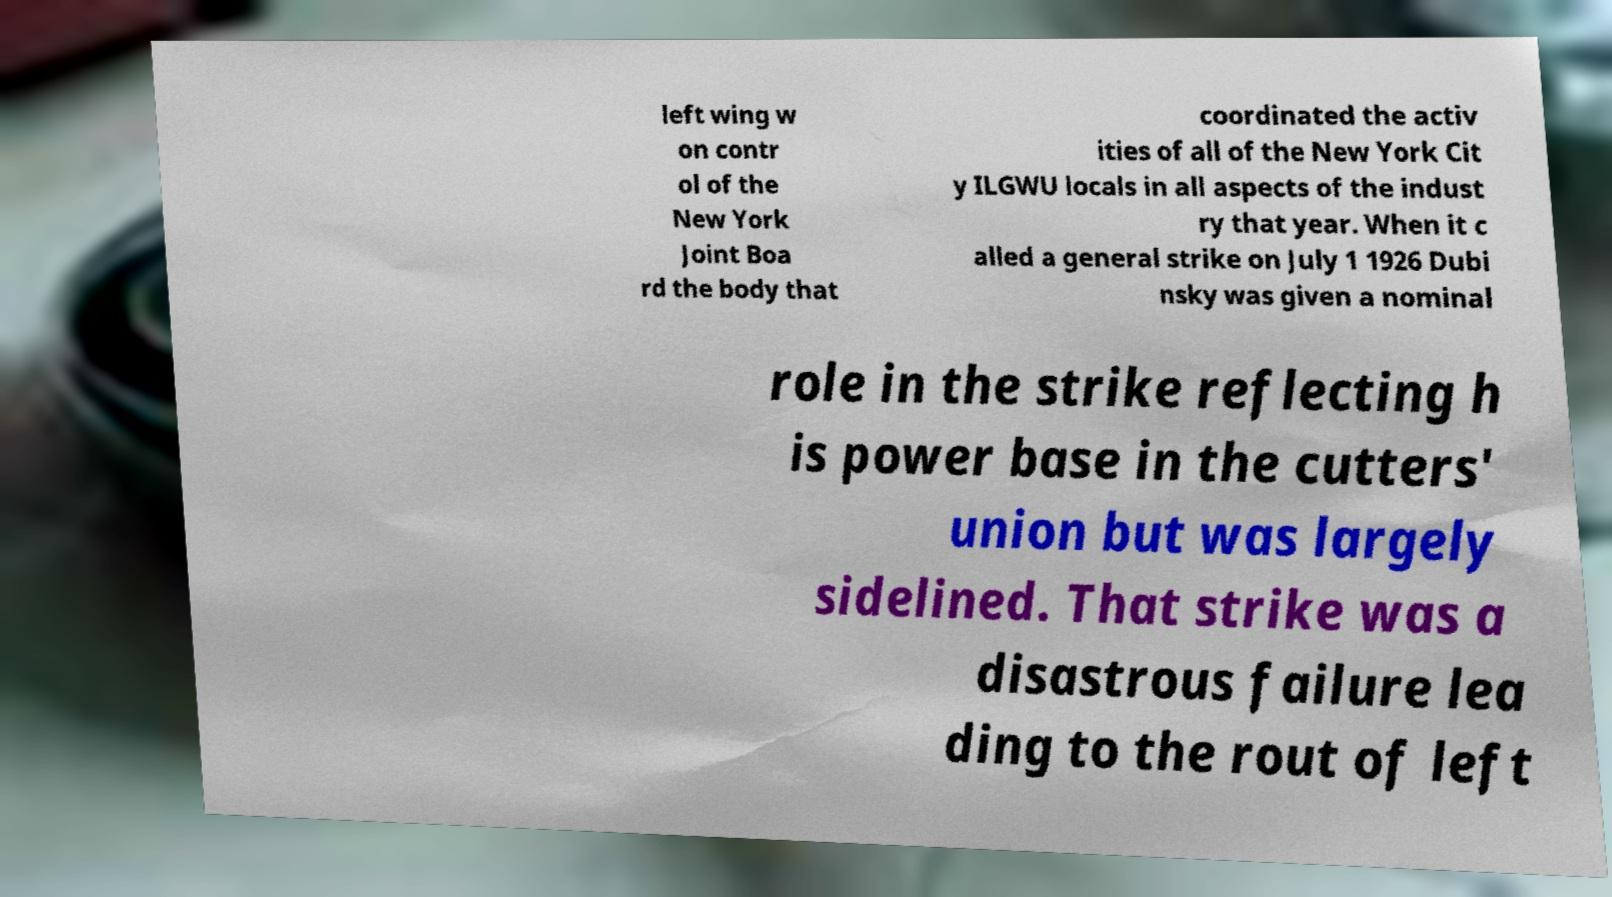Could you assist in decoding the text presented in this image and type it out clearly? left wing w on contr ol of the New York Joint Boa rd the body that coordinated the activ ities of all of the New York Cit y ILGWU locals in all aspects of the indust ry that year. When it c alled a general strike on July 1 1926 Dubi nsky was given a nominal role in the strike reflecting h is power base in the cutters' union but was largely sidelined. That strike was a disastrous failure lea ding to the rout of left 